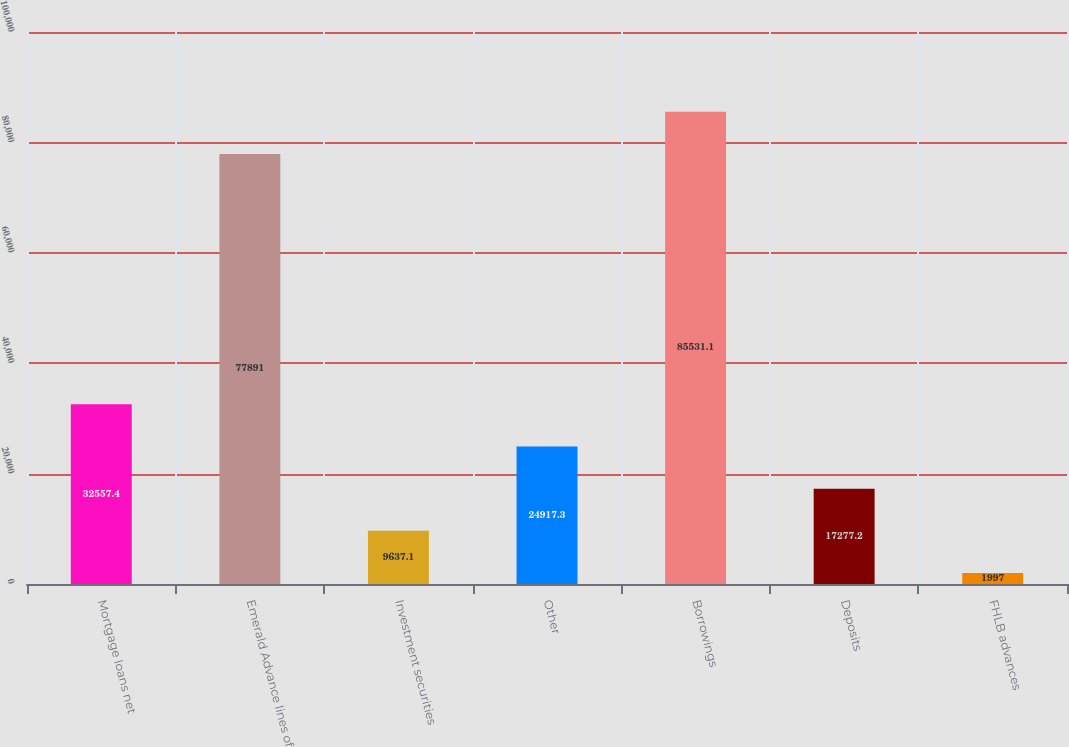Convert chart to OTSL. <chart><loc_0><loc_0><loc_500><loc_500><bar_chart><fcel>Mortgage loans net<fcel>Emerald Advance lines of<fcel>Investment securities<fcel>Other<fcel>Borrowings<fcel>Deposits<fcel>FHLB advances<nl><fcel>32557.4<fcel>77891<fcel>9637.1<fcel>24917.3<fcel>85531.1<fcel>17277.2<fcel>1997<nl></chart> 